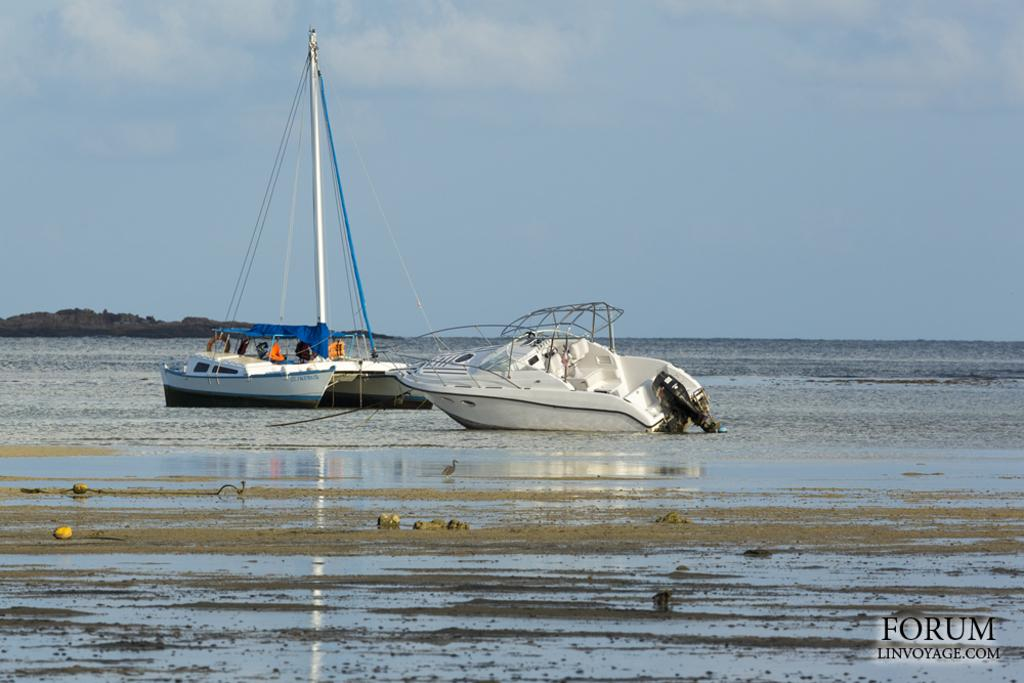What can be seen in the foreground of the picture? In the foreground of the picture, there are stones, mud, a bird, and water. What is located in the center of the picture? In the center of the picture, there are boats in the water. What is present in the background of the picture? In the background of the picture, there is a rock. How would you describe the sky in the image? The sky is cloudy. What type of straw is being used for the activity in the image? There is no activity involving straw in the image. What type of quilt is covering the bird in the image? There is no quilt present in the image; the bird is not covered. 